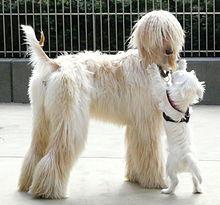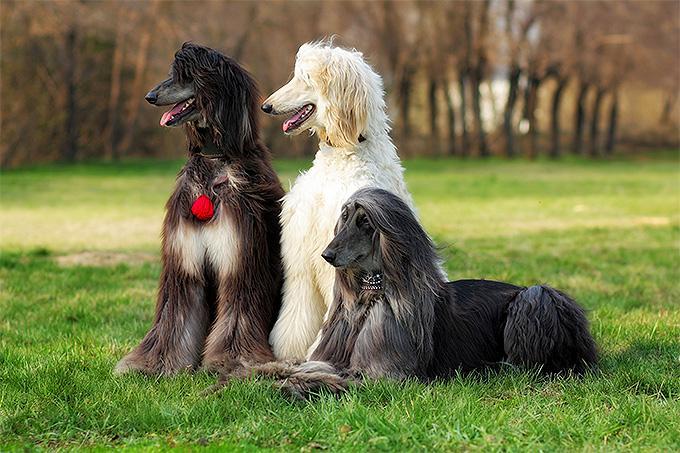The first image is the image on the left, the second image is the image on the right. For the images shown, is this caption "Each image shows one blonde hound with long silky hair standing on a green grassy area." true? Answer yes or no. No. The first image is the image on the left, the second image is the image on the right. For the images shown, is this caption "The dogs in the two images have their bodies turned toward each other, and their heads both turned in the same direction." true? Answer yes or no. No. The first image is the image on the left, the second image is the image on the right. Considering the images on both sides, is "Both dogs are standing on a grassy area." valid? Answer yes or no. No. The first image is the image on the left, the second image is the image on the right. Examine the images to the left and right. Is the description "The dog in both images are standing in the grass." accurate? Answer yes or no. No. 